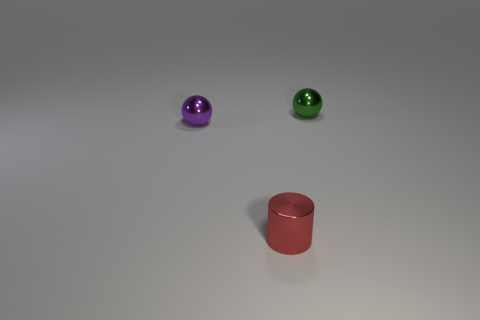Add 2 big gray rubber spheres. How many objects exist? 5 Subtract 1 balls. How many balls are left? 1 Add 3 small red shiny objects. How many small red shiny objects exist? 4 Subtract all green spheres. How many spheres are left? 1 Subtract 0 brown cylinders. How many objects are left? 3 Subtract all cylinders. How many objects are left? 2 Subtract all cyan spheres. Subtract all brown cylinders. How many spheres are left? 2 Subtract all blue blocks. How many brown cylinders are left? 0 Subtract all red metallic cylinders. Subtract all yellow matte spheres. How many objects are left? 2 Add 1 small metallic cylinders. How many small metallic cylinders are left? 2 